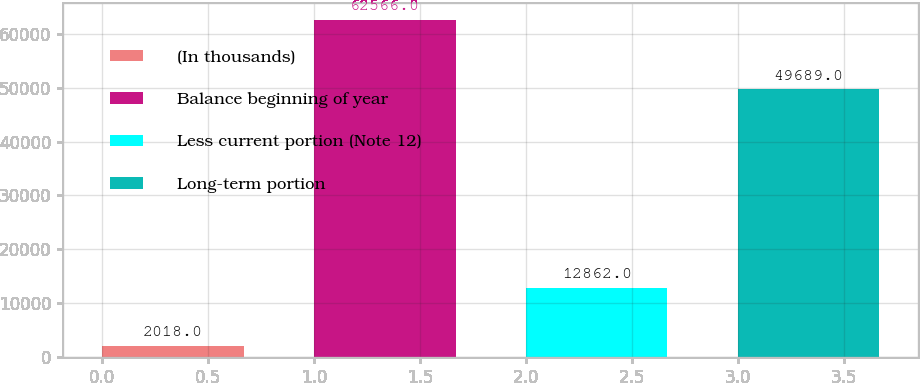<chart> <loc_0><loc_0><loc_500><loc_500><bar_chart><fcel>(In thousands)<fcel>Balance beginning of year<fcel>Less current portion (Note 12)<fcel>Long-term portion<nl><fcel>2018<fcel>62566<fcel>12862<fcel>49689<nl></chart> 